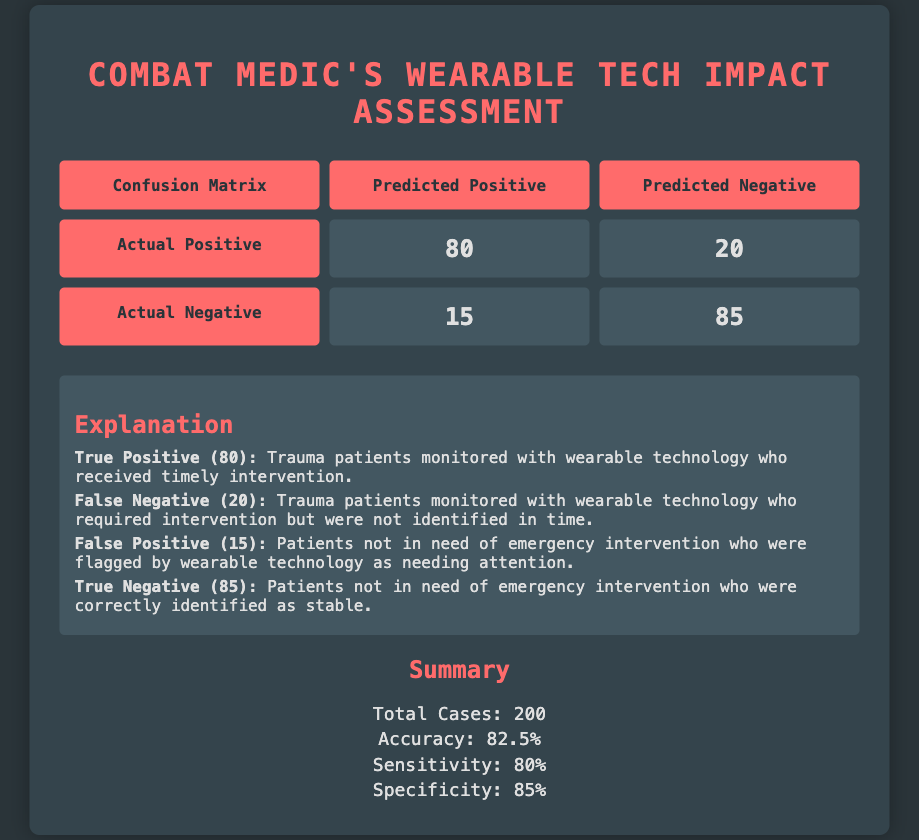What is the total number of true positives in the confusion matrix? The true positive count is directly taken from the confusion matrix, where "true positive" refers to trauma patients monitored with wearable technology who received timely intervention. The value is stated as 80 in the matrix.
Answer: 80 How many patients were incorrectly flagged by the wearable technology as needing intervention? The number of patients incorrectly flagged, known as false positives, is 15 as stated in the confusion matrix under the column for predicted positive and the row for actual negative.
Answer: 15 What percentage of trauma patients were correctly identified as needing intervention? The percentage of correctly identified trauma patients is represented by sensitivity in the summary section, which is given as 80%. Sensitivity reflects the proportion of true positives to the total actual positives.
Answer: 80% What is the accuracy of the wearable technology in identifying trauma patients? The accuracy of the wearable technology is mentioned in the summary section as 82.5%. This figure is derived from the total number of correct predictions (both true positives and true negatives) divided by the total cases.
Answer: 82.5% Is it true that the wearable technology had more true negatives than false positives? True negatives are indicated as 85, while false positives are 15. Since 85 is greater than 15, it confirms that true negatives outnumbered false positives, making the statement true.
Answer: Yes How many total cases were evaluated in this assessment? The total number of cases evaluated is specified in the summary as 200, which is the sum of true positives, false negatives, false positives, and true negatives.
Answer: 200 What is the ratio of true positives to false negatives? The ratio of true positives (80) to false negatives (20) can be calculated by dividing the number of true positives by the number of false negatives, resulting in a ratio of 80:20, which simplifies to 4:1.
Answer: 4:1 How many patients were correctly identified as stable? The number of patients correctly identified as stable corresponds to true negatives, which is indicated as 85 in the confusion matrix under the column for predicted negative and the row for actual negative.
Answer: 85 What is the specificity of the wearable technology? Specificity is mentioned in the summary as 85%. This value represents the proportion of true negatives (85) to the total actual negatives (true negatives plus false positives: 85 + 15 = 100). Thus, specificity is calculated as (true negatives / total actual negatives) * 100.
Answer: 85% 